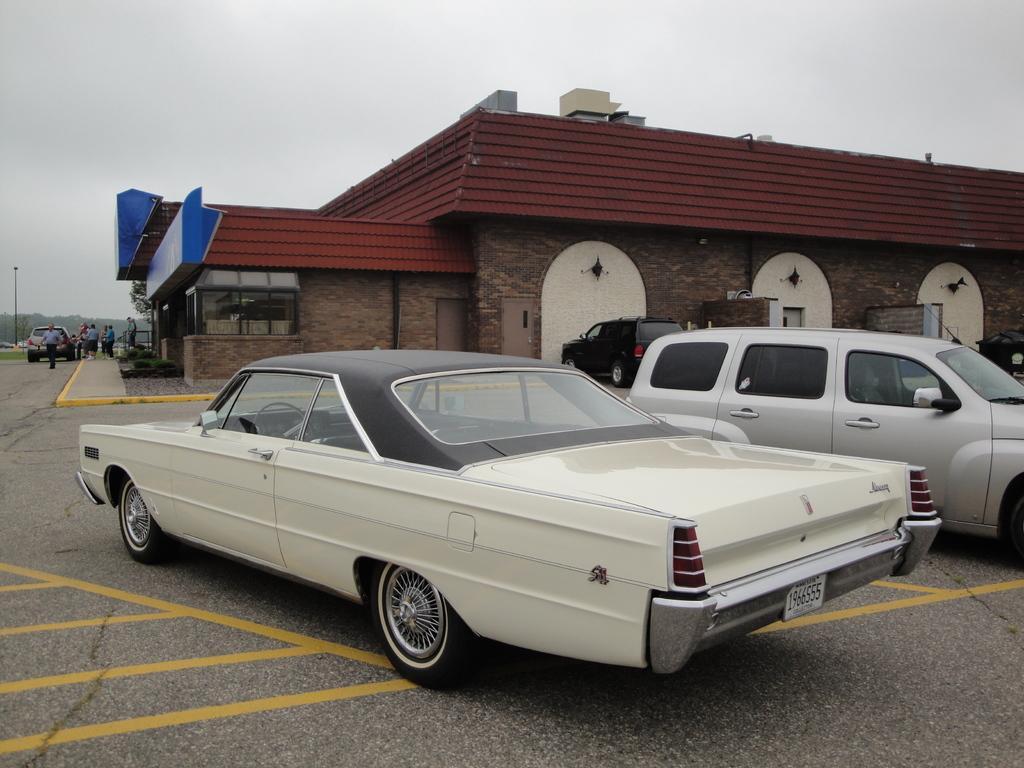In one or two sentences, can you explain what this image depicts? There are vehicles on the road. In the background, there are persons, a vehicle, a building, trees and there are clouds in the sky. 